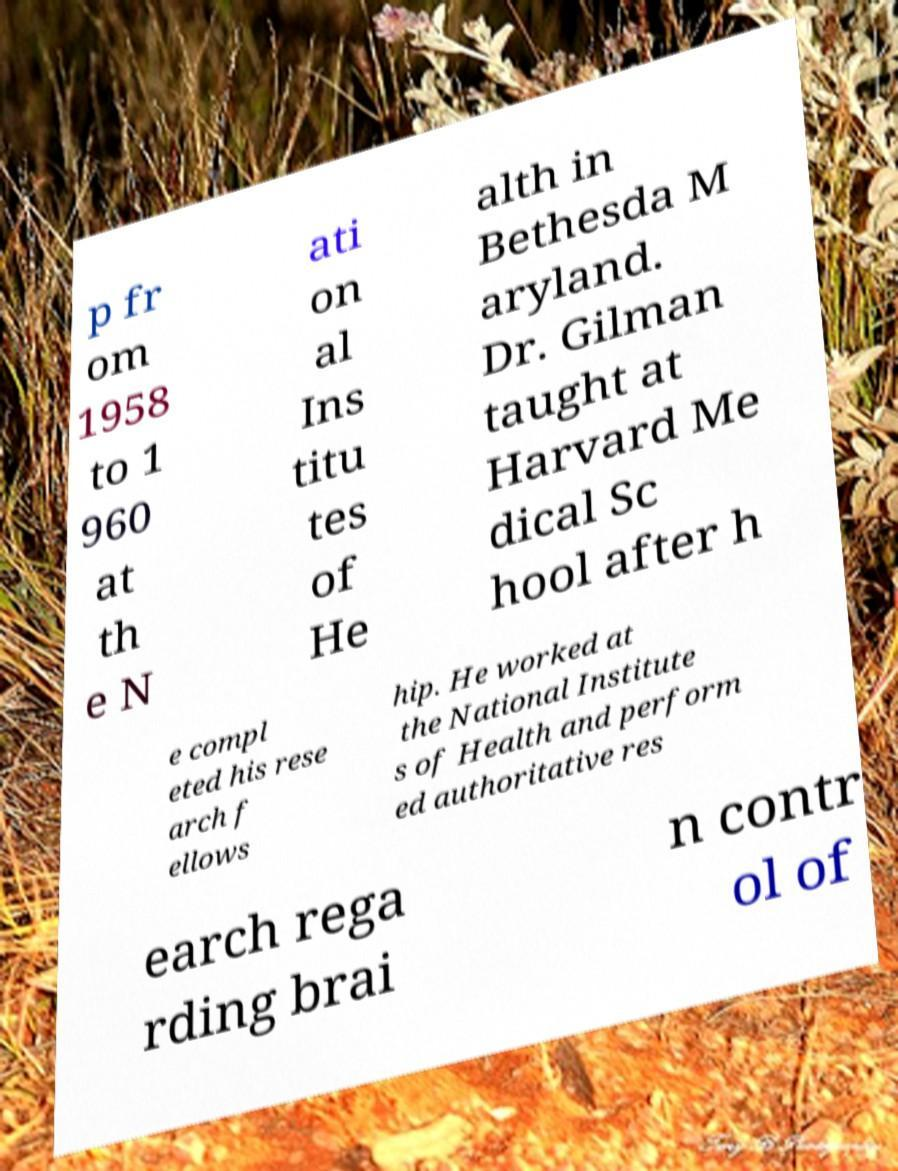Could you extract and type out the text from this image? p fr om 1958 to 1 960 at th e N ati on al Ins titu tes of He alth in Bethesda M aryland. Dr. Gilman taught at Harvard Me dical Sc hool after h e compl eted his rese arch f ellows hip. He worked at the National Institute s of Health and perform ed authoritative res earch rega rding brai n contr ol of 